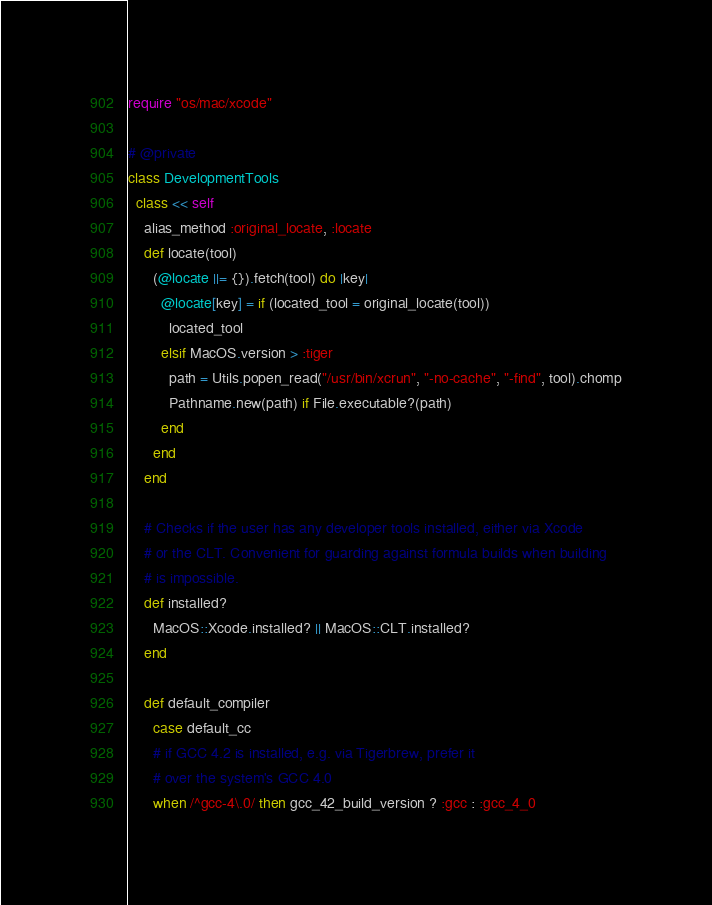<code> <loc_0><loc_0><loc_500><loc_500><_Ruby_>require "os/mac/xcode"

# @private
class DevelopmentTools
  class << self
    alias_method :original_locate, :locate
    def locate(tool)
      (@locate ||= {}).fetch(tool) do |key|
        @locate[key] = if (located_tool = original_locate(tool))
          located_tool
        elsif MacOS.version > :tiger
          path = Utils.popen_read("/usr/bin/xcrun", "-no-cache", "-find", tool).chomp
          Pathname.new(path) if File.executable?(path)
        end
      end
    end

    # Checks if the user has any developer tools installed, either via Xcode
    # or the CLT. Convenient for guarding against formula builds when building
    # is impossible.
    def installed?
      MacOS::Xcode.installed? || MacOS::CLT.installed?
    end

    def default_compiler
      case default_cc
      # if GCC 4.2 is installed, e.g. via Tigerbrew, prefer it
      # over the system's GCC 4.0
      when /^gcc-4\.0/ then gcc_42_build_version ? :gcc : :gcc_4_0</code> 